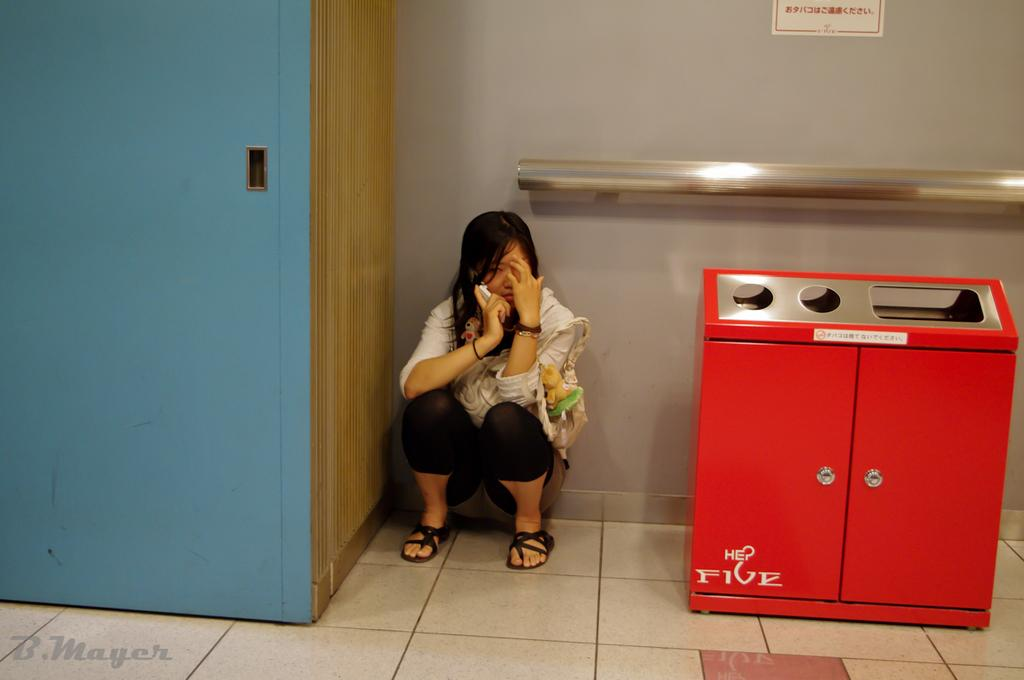<image>
Give a short and clear explanation of the subsequent image. A woman sits crouched talking on the phone next to a HE Five trash can. 